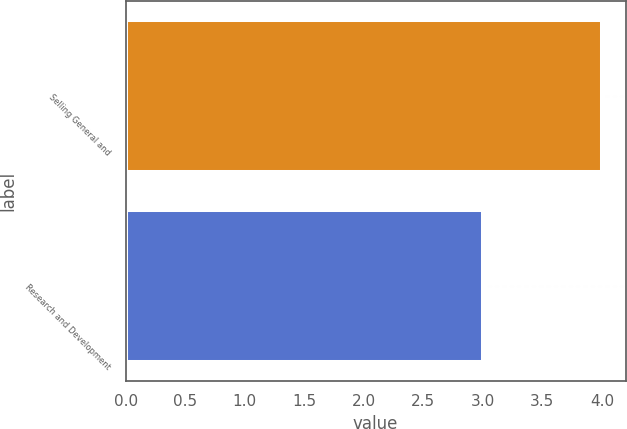Convert chart to OTSL. <chart><loc_0><loc_0><loc_500><loc_500><bar_chart><fcel>Selling General and<fcel>Research and Development<nl><fcel>4<fcel>3<nl></chart> 